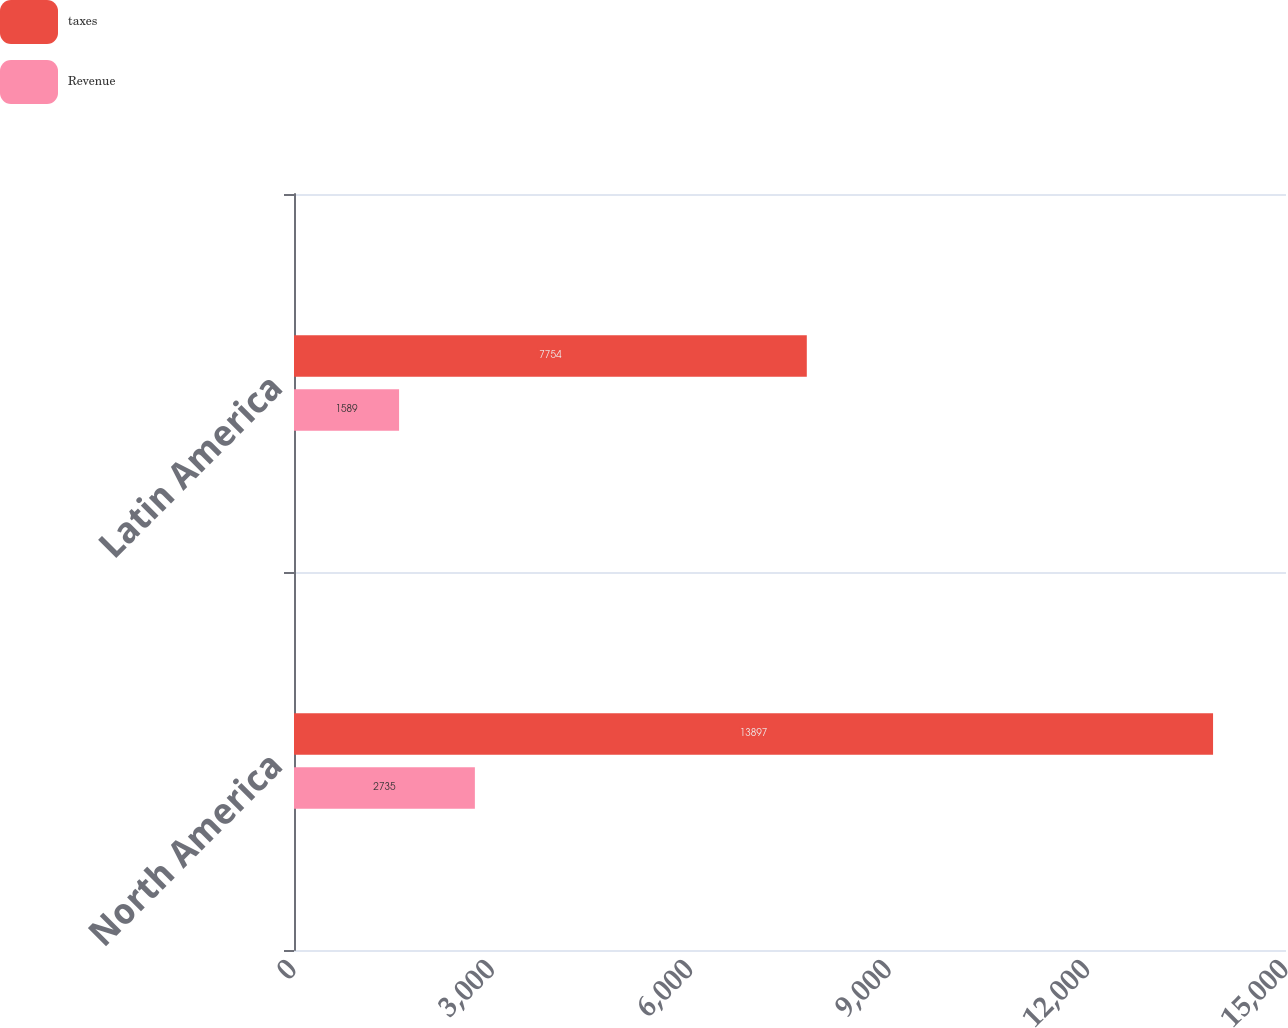<chart> <loc_0><loc_0><loc_500><loc_500><stacked_bar_chart><ecel><fcel>North America<fcel>Latin America<nl><fcel>taxes<fcel>13897<fcel>7754<nl><fcel>Revenue<fcel>2735<fcel>1589<nl></chart> 